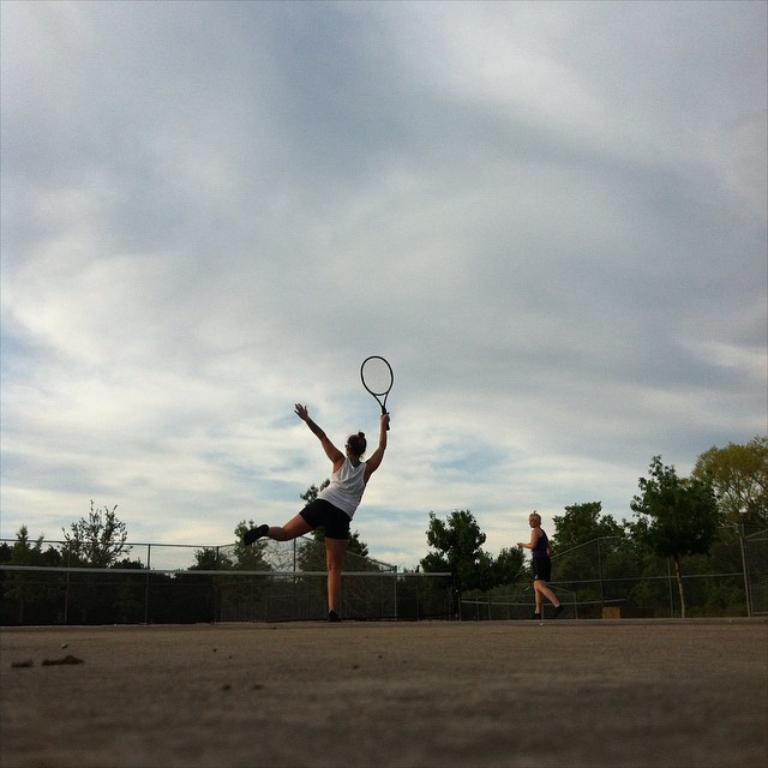How many people are in the image? There are two people in the image. What are the people wearing? The people are wearing different color dresses. What is one person holding in the image? One person is holding a racket. What can be seen in the background of the image? There is a net fence and many trees in the background of the image. What is visible in the sky in the image? There are clouds visible in the sky, and the sky is visible in the background of the image. How many pizzas are being served on the table in the image? There is no table or pizzas present in the image. What type of finger is being used to play the racket in the image? There is no finger being used to play the racket in the image; it is held by one of the people. 